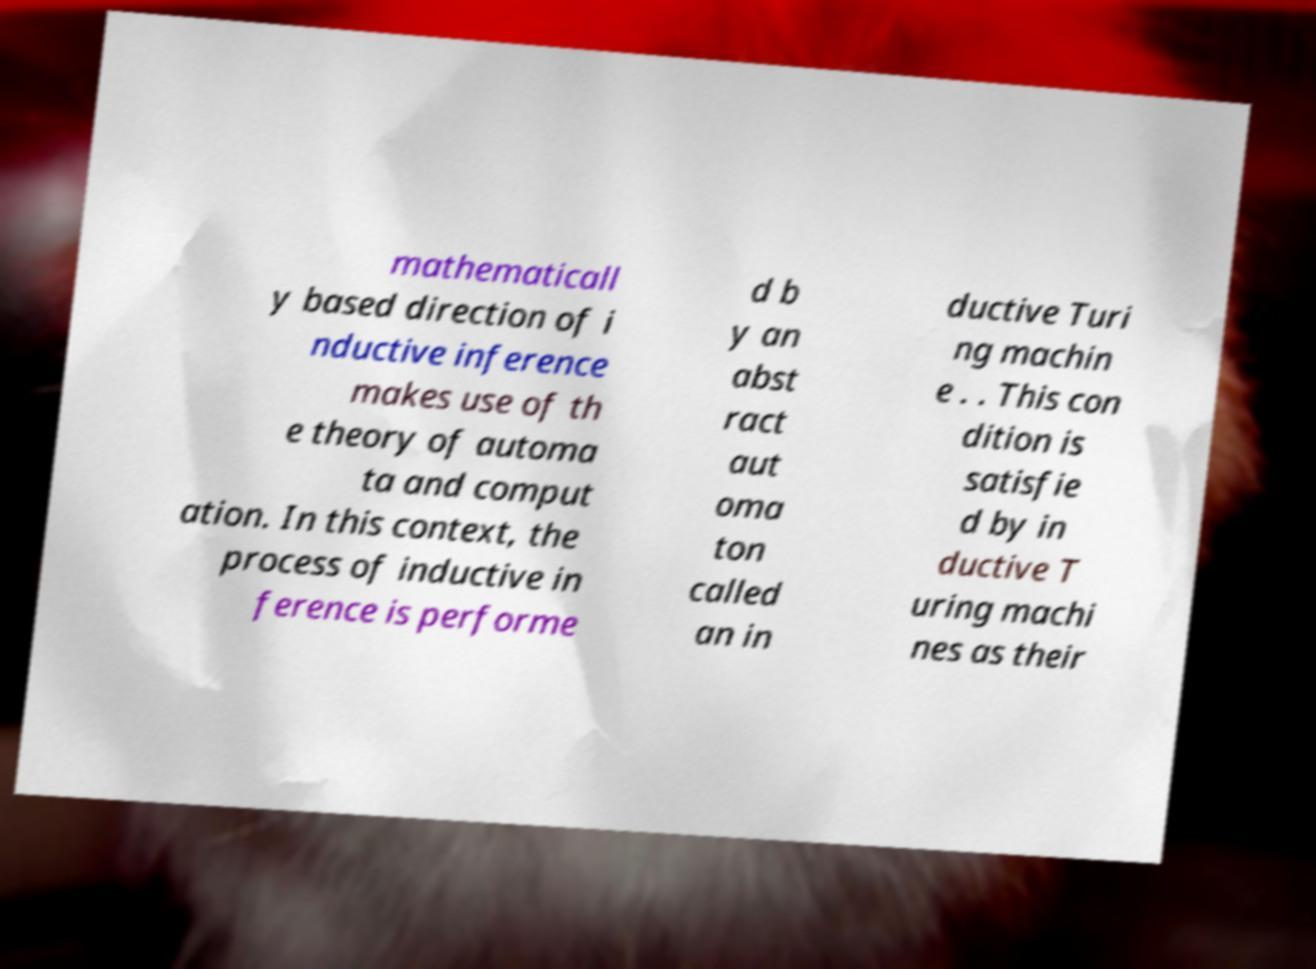Could you extract and type out the text from this image? mathematicall y based direction of i nductive inference makes use of th e theory of automa ta and comput ation. In this context, the process of inductive in ference is performe d b y an abst ract aut oma ton called an in ductive Turi ng machin e . . This con dition is satisfie d by in ductive T uring machi nes as their 